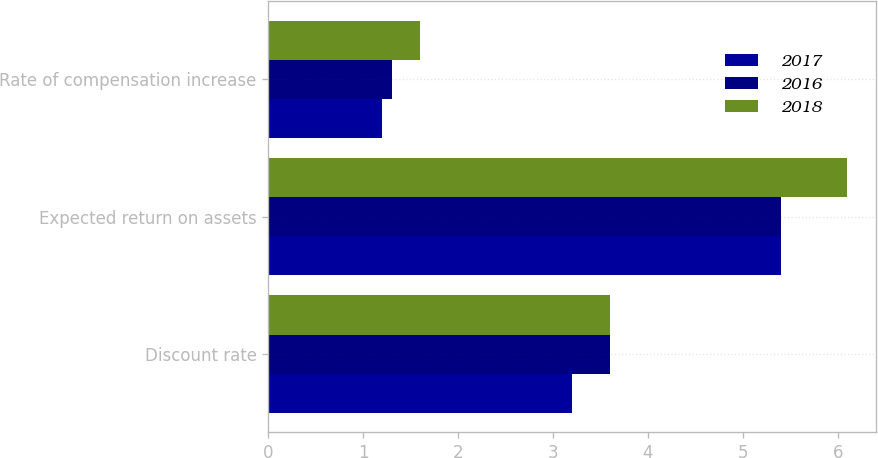Convert chart. <chart><loc_0><loc_0><loc_500><loc_500><stacked_bar_chart><ecel><fcel>Discount rate<fcel>Expected return on assets<fcel>Rate of compensation increase<nl><fcel>2017<fcel>3.2<fcel>5.4<fcel>1.2<nl><fcel>2016<fcel>3.6<fcel>5.4<fcel>1.3<nl><fcel>2018<fcel>3.6<fcel>6.1<fcel>1.6<nl></chart> 